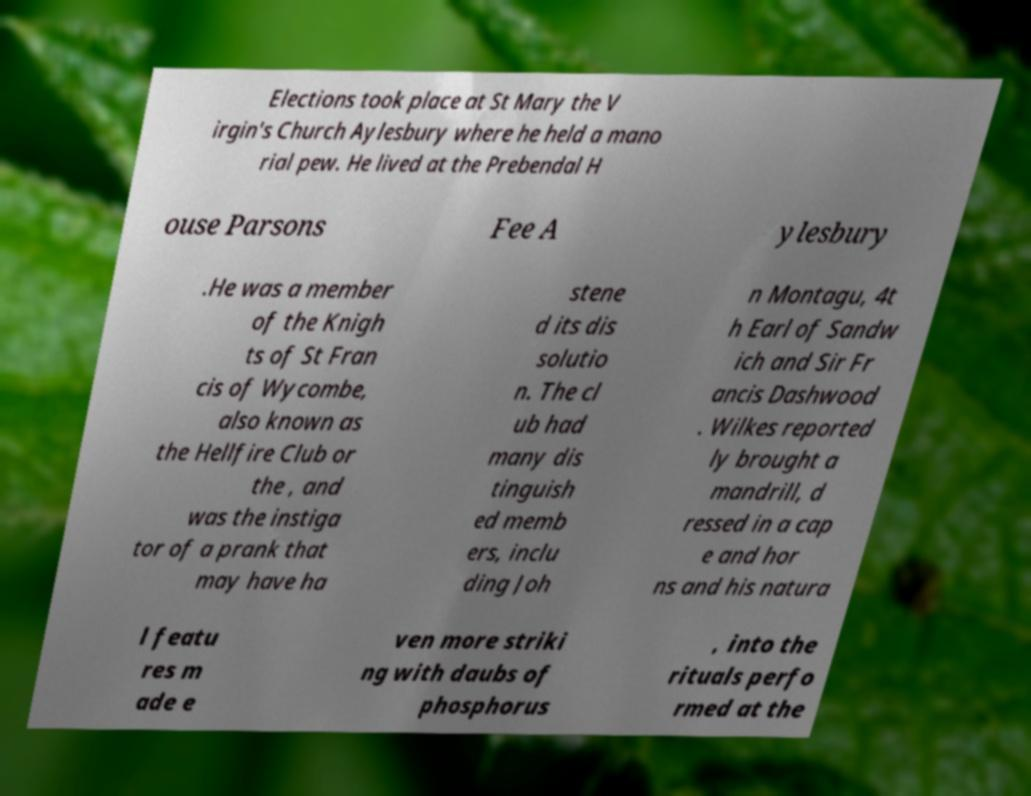Can you accurately transcribe the text from the provided image for me? Elections took place at St Mary the V irgin's Church Aylesbury where he held a mano rial pew. He lived at the Prebendal H ouse Parsons Fee A ylesbury .He was a member of the Knigh ts of St Fran cis of Wycombe, also known as the Hellfire Club or the , and was the instiga tor of a prank that may have ha stene d its dis solutio n. The cl ub had many dis tinguish ed memb ers, inclu ding Joh n Montagu, 4t h Earl of Sandw ich and Sir Fr ancis Dashwood . Wilkes reported ly brought a mandrill, d ressed in a cap e and hor ns and his natura l featu res m ade e ven more striki ng with daubs of phosphorus , into the rituals perfo rmed at the 